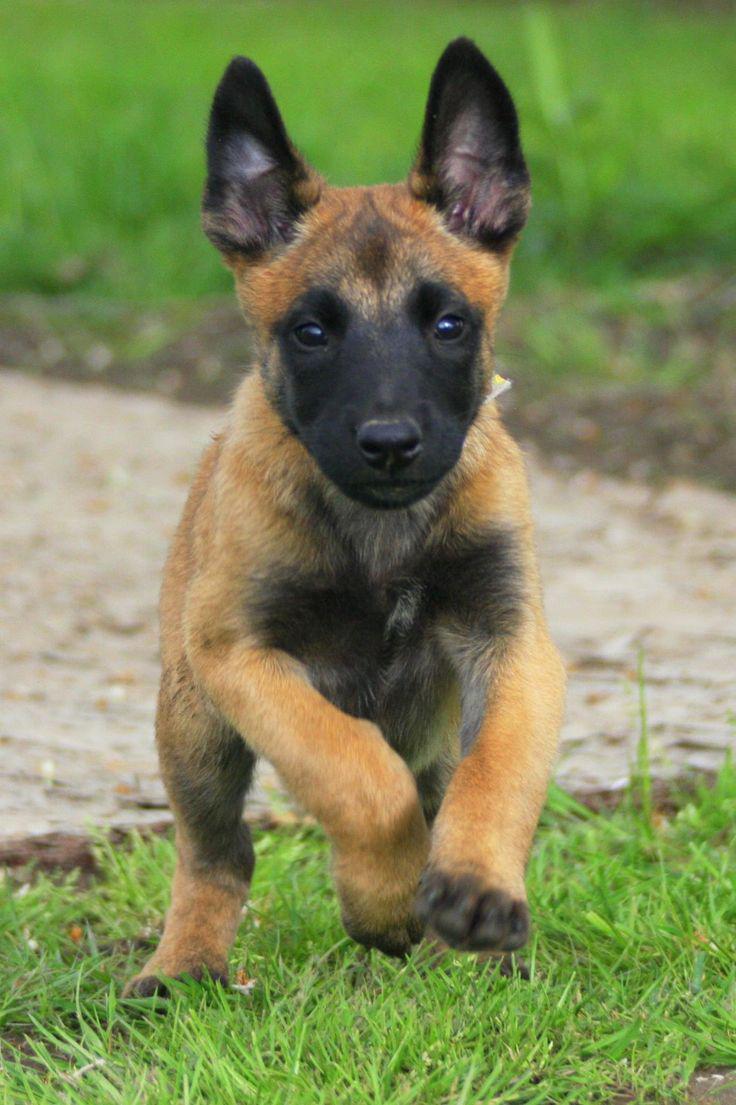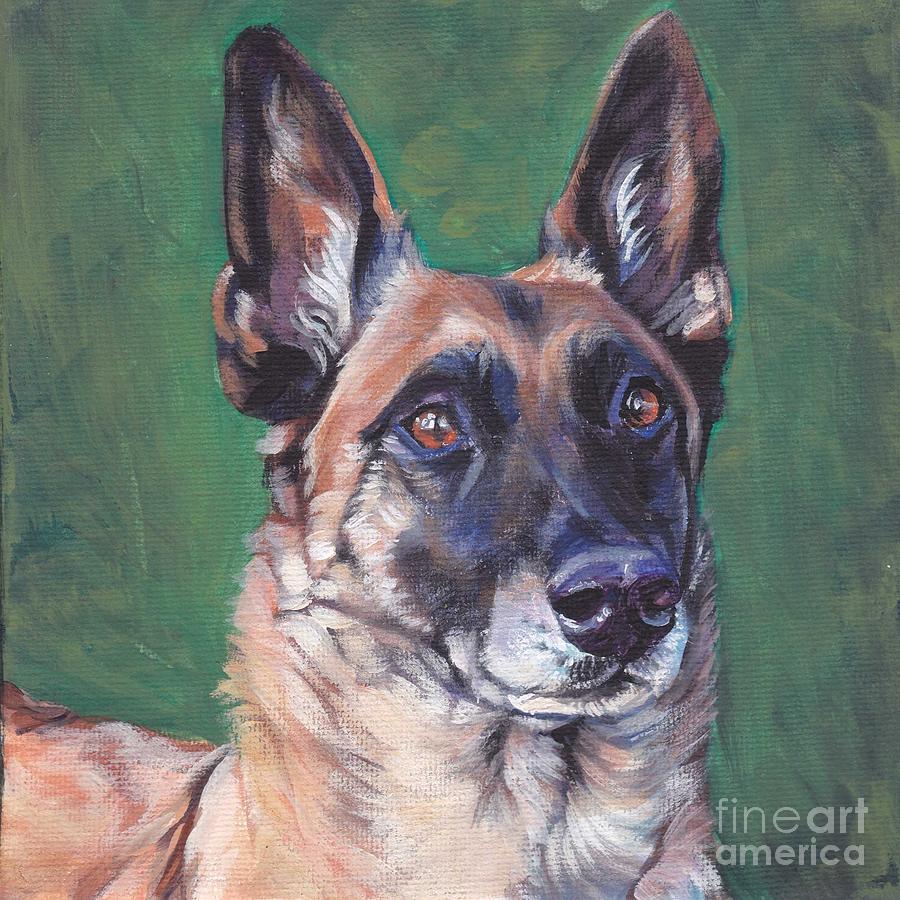The first image is the image on the left, the second image is the image on the right. Examine the images to the left and right. Is the description "The dog on the left is lying down in the grass." accurate? Answer yes or no. No. 